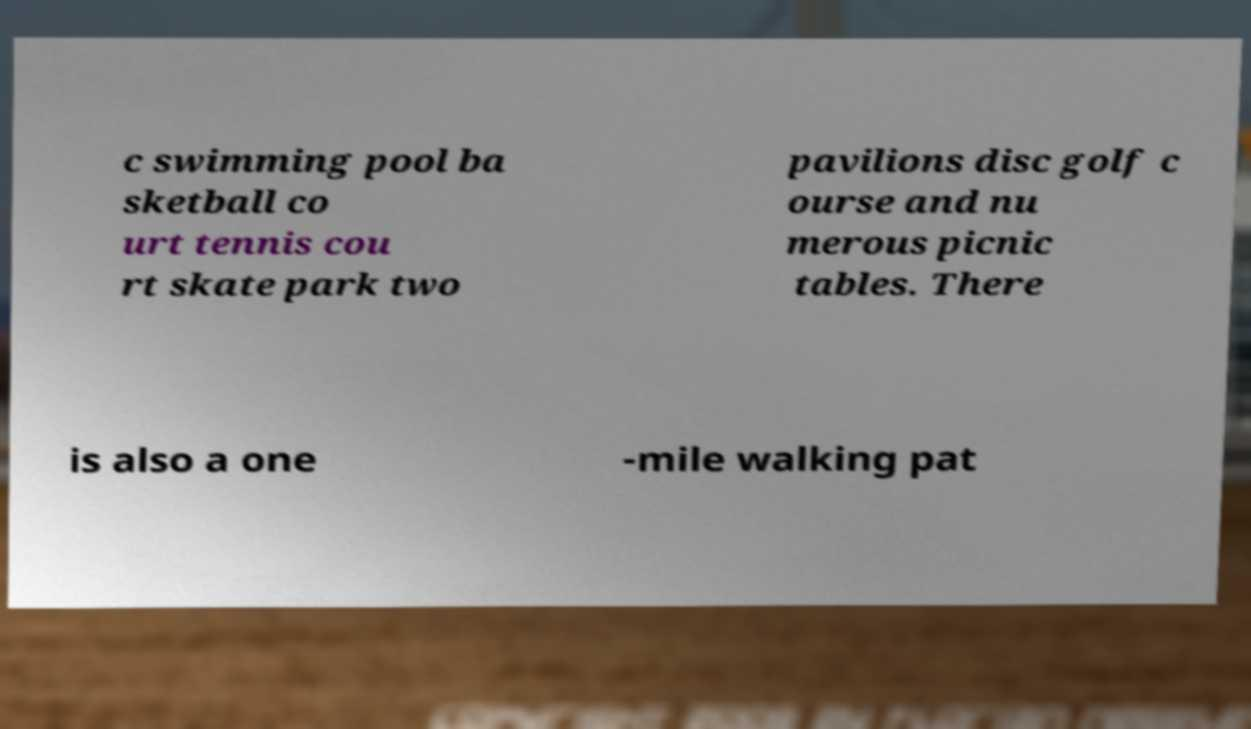Please read and relay the text visible in this image. What does it say? c swimming pool ba sketball co urt tennis cou rt skate park two pavilions disc golf c ourse and nu merous picnic tables. There is also a one -mile walking pat 